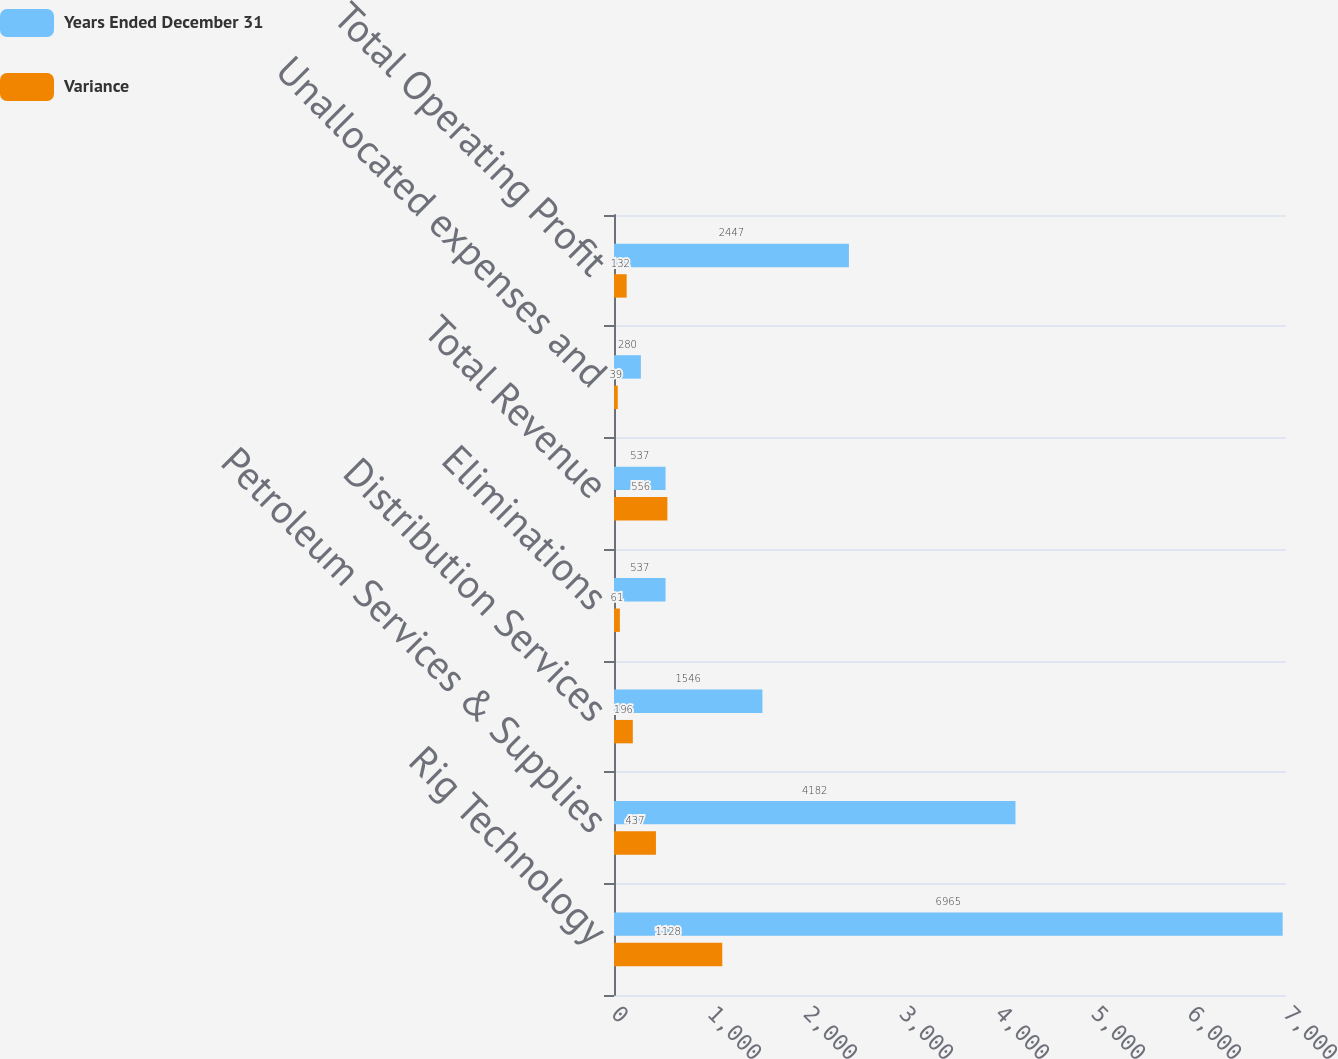Convert chart to OTSL. <chart><loc_0><loc_0><loc_500><loc_500><stacked_bar_chart><ecel><fcel>Rig Technology<fcel>Petroleum Services & Supplies<fcel>Distribution Services<fcel>Eliminations<fcel>Total Revenue<fcel>Unallocated expenses and<fcel>Total Operating Profit<nl><fcel>Years Ended December 31<fcel>6965<fcel>4182<fcel>1546<fcel>537<fcel>537<fcel>280<fcel>2447<nl><fcel>Variance<fcel>1128<fcel>437<fcel>196<fcel>61<fcel>556<fcel>39<fcel>132<nl></chart> 